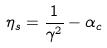Convert formula to latex. <formula><loc_0><loc_0><loc_500><loc_500>\eta _ { s } = \frac { 1 } { \gamma ^ { 2 } } - \alpha _ { c }</formula> 